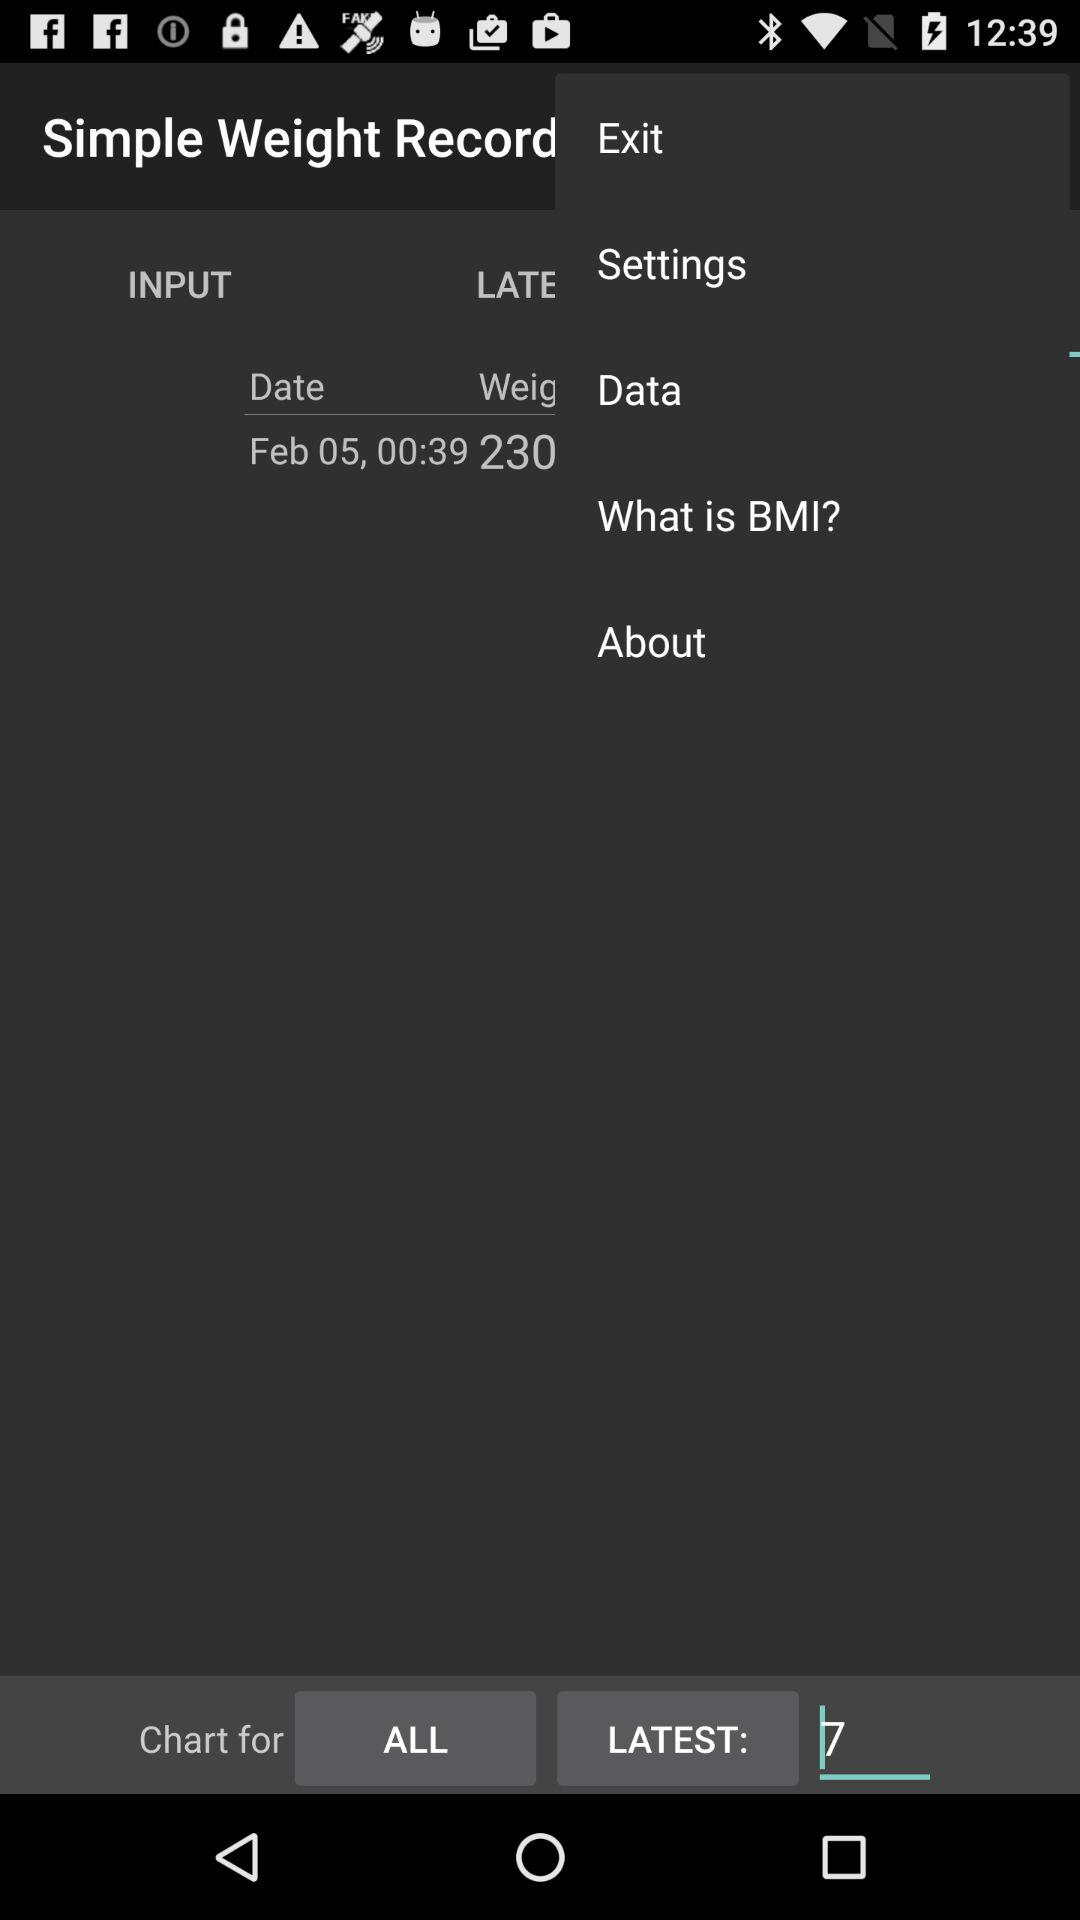What is the weight? The weight is 230. 